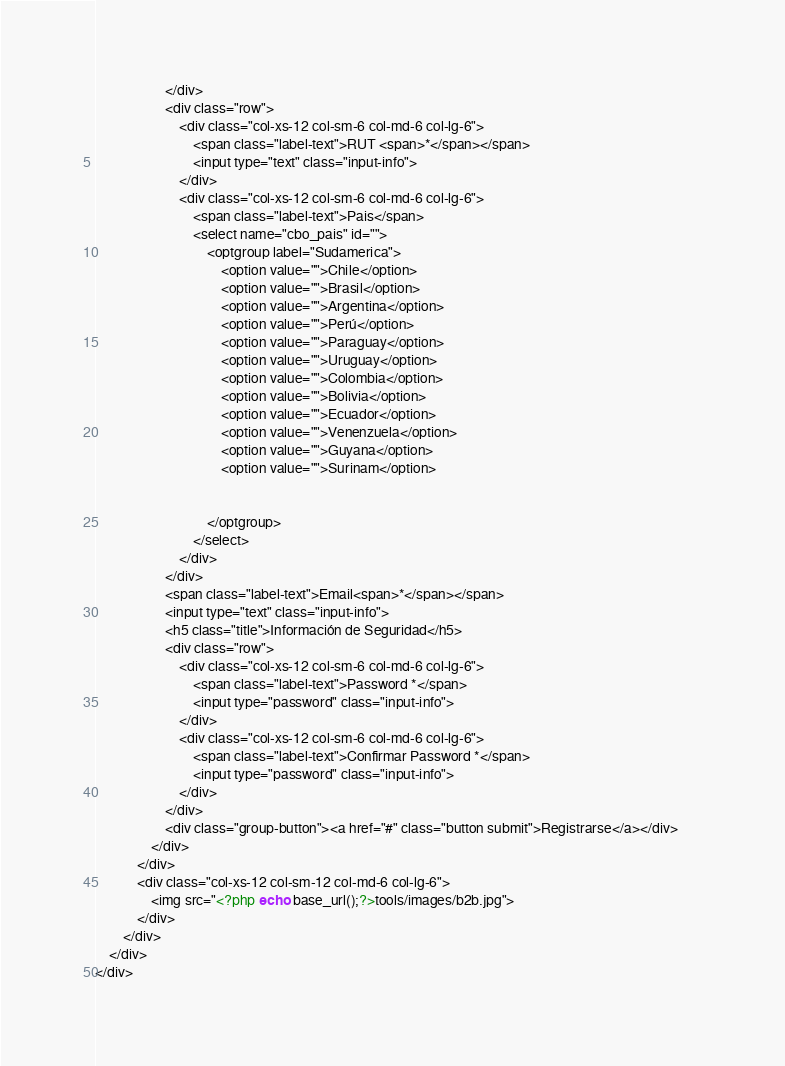Convert code to text. <code><loc_0><loc_0><loc_500><loc_500><_PHP_>                    </div>
                    <div class="row">
                        <div class="col-xs-12 col-sm-6 col-md-6 col-lg-6">
                            <span class="label-text">RUT <span>*</span></span>
                            <input type="text" class="input-info">
                        </div>
                        <div class="col-xs-12 col-sm-6 col-md-6 col-lg-6">
                            <span class="label-text">Pais</span>
                            <select name="cbo_pais" id="">
                                <optgroup label="Sudamerica">
                                    <option value="">Chile</option>
                                    <option value="">Brasil</option>
                                    <option value="">Argentina</option>
                                    <option value="">Perú</option>
                                    <option value="">Paraguay</option>
                                    <option value="">Uruguay</option>
                                    <option value="">Colombia</option>
                                    <option value="">Bolivia</option>
                                    <option value="">Ecuador</option>
                                    <option value="">Venenzuela</option>
                                    <option value="">Guyana</option>
                                    <option value="">Surinam</option>
                                         
                                    
                                </optgroup>
                            </select>
                        </div>
                    </div>	
                    <span class="label-text">Email<span>*</span></span>
                    <input type="text" class="input-info">	
                    <h5 class="title">Información de Seguridad</h5>
                    <div class="row">
                        <div class="col-xs-12 col-sm-6 col-md-6 col-lg-6">
                            <span class="label-text">Password *</span>
                            <input type="password" class="input-info">
                        </div>
                        <div class="col-xs-12 col-sm-6 col-md-6 col-lg-6">
                            <span class="label-text">Confirmar Password *</span>
                            <input type="password" class="input-info">	
                        </div>
                    </div>
                    <div class="group-button"><a href="#" class="button submit">Registrarse</a></div>		
                </div>
            </div>
            <div class="col-xs-12 col-sm-12 col-md-6 col-lg-6">
                <img src="<?php echo base_url();?>tools/images/b2b.jpg">
            </div>
        </div>
    </div>
</div></code> 